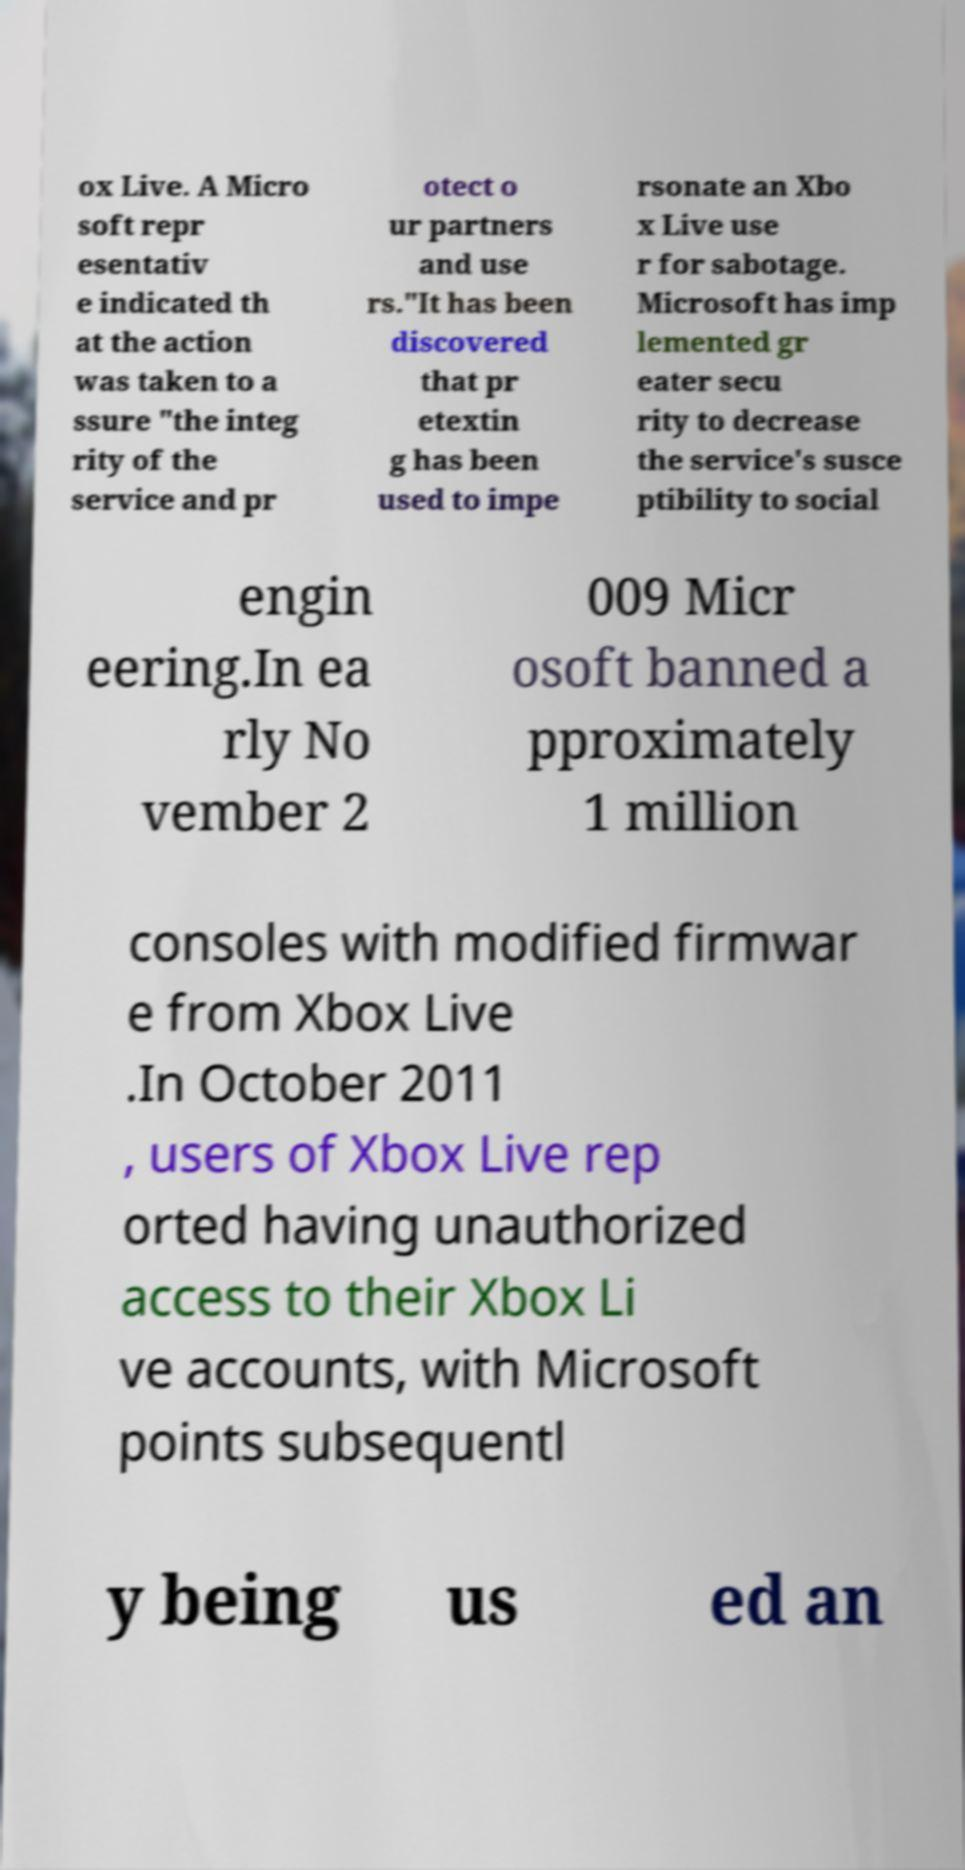There's text embedded in this image that I need extracted. Can you transcribe it verbatim? ox Live. A Micro soft repr esentativ e indicated th at the action was taken to a ssure "the integ rity of the service and pr otect o ur partners and use rs."It has been discovered that pr etextin g has been used to impe rsonate an Xbo x Live use r for sabotage. Microsoft has imp lemented gr eater secu rity to decrease the service's susce ptibility to social engin eering.In ea rly No vember 2 009 Micr osoft banned a pproximately 1 million consoles with modified firmwar e from Xbox Live .In October 2011 , users of Xbox Live rep orted having unauthorized access to their Xbox Li ve accounts, with Microsoft points subsequentl y being us ed an 